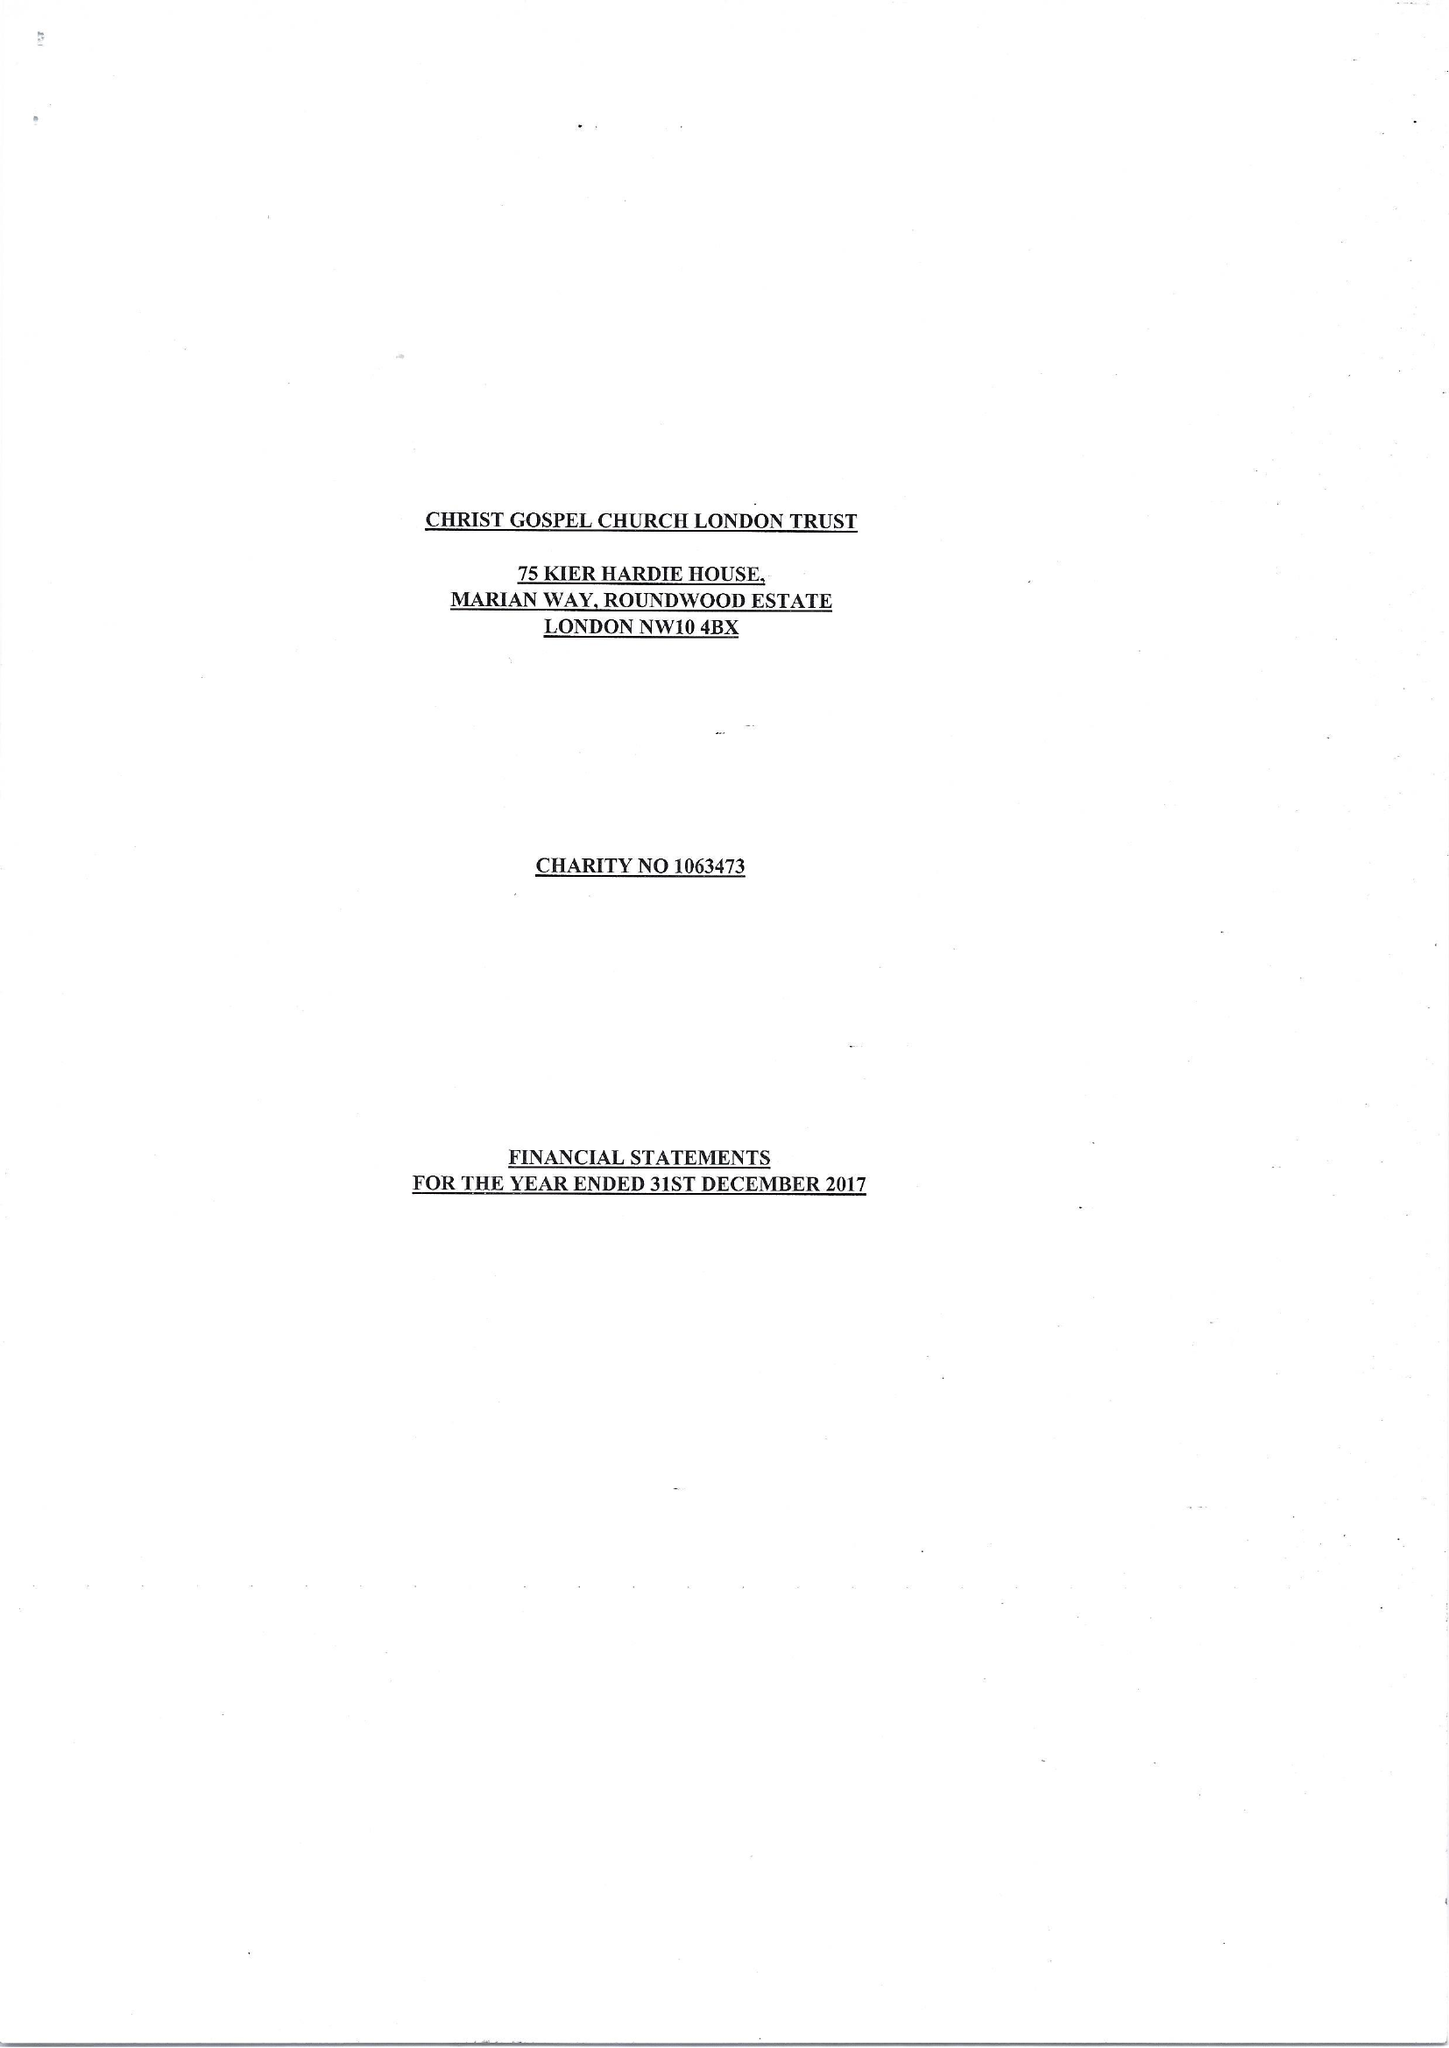What is the value for the charity_name?
Answer the question using a single word or phrase. Christ Gospel Church London Trust 